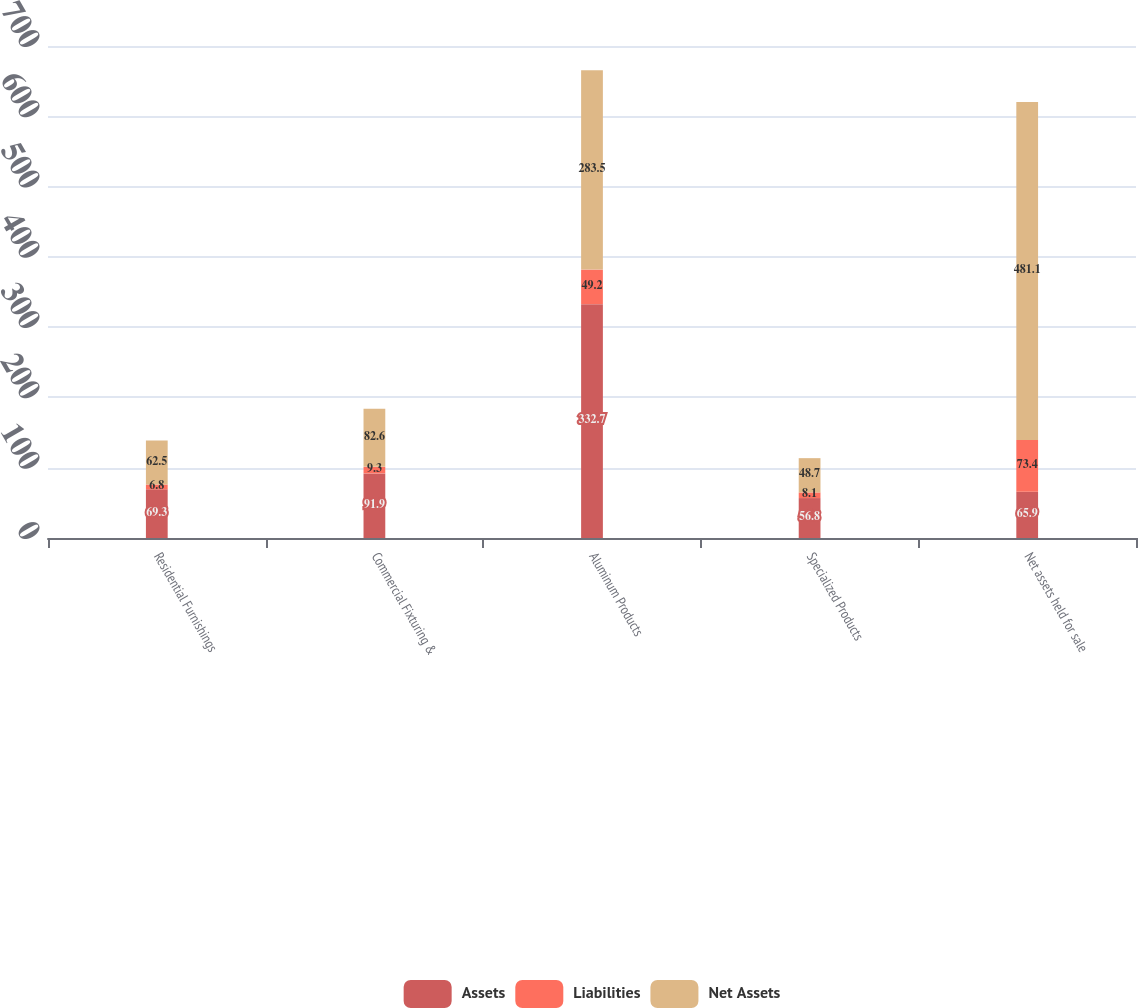Convert chart. <chart><loc_0><loc_0><loc_500><loc_500><stacked_bar_chart><ecel><fcel>Residential Furnishings<fcel>Commercial Fixturing &<fcel>Aluminum Products<fcel>Specialized Products<fcel>Net assets held for sale<nl><fcel>Assets<fcel>69.3<fcel>91.9<fcel>332.7<fcel>56.8<fcel>65.9<nl><fcel>Liabilities<fcel>6.8<fcel>9.3<fcel>49.2<fcel>8.1<fcel>73.4<nl><fcel>Net Assets<fcel>62.5<fcel>82.6<fcel>283.5<fcel>48.7<fcel>481.1<nl></chart> 